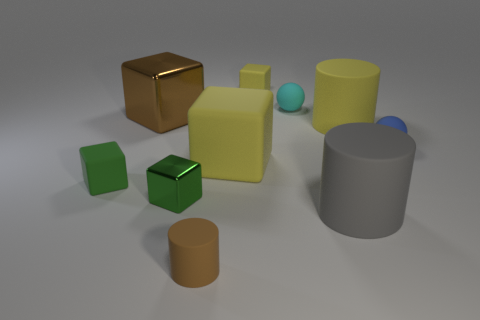There is a brown metal block; what number of objects are to the right of it?
Give a very brief answer. 8. What is the color of the big shiny object that is the same shape as the small green shiny object?
Keep it short and to the point. Brown. Is the material of the large thing on the right side of the big gray rubber cylinder the same as the big object that is left of the large yellow matte block?
Your answer should be very brief. No. There is a small metallic block; is its color the same as the tiny rubber object to the left of the tiny cylinder?
Your answer should be very brief. Yes. There is a yellow thing that is in front of the tiny cyan matte ball and to the left of the cyan object; what shape is it?
Keep it short and to the point. Cube. How many rubber blocks are there?
Offer a terse response. 3. There is a thing that is the same color as the tiny cylinder; what shape is it?
Provide a short and direct response. Cube. There is a blue matte object that is the same shape as the small cyan rubber object; what size is it?
Offer a terse response. Small. Do the yellow matte thing behind the large brown cube and the large gray matte object have the same shape?
Your answer should be very brief. No. What is the color of the tiny cube that is behind the tiny green matte thing?
Make the answer very short. Yellow. 